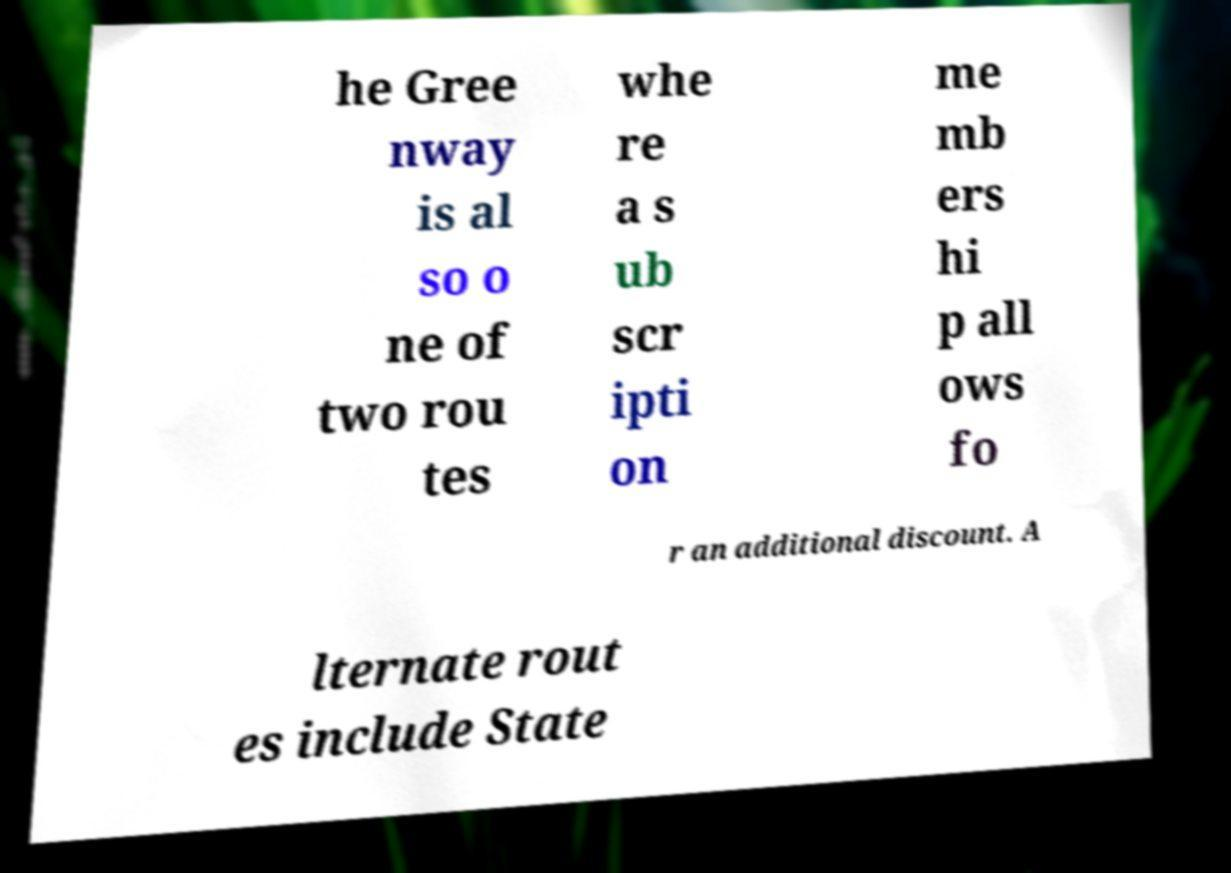What messages or text are displayed in this image? I need them in a readable, typed format. he Gree nway is al so o ne of two rou tes whe re a s ub scr ipti on me mb ers hi p all ows fo r an additional discount. A lternate rout es include State 